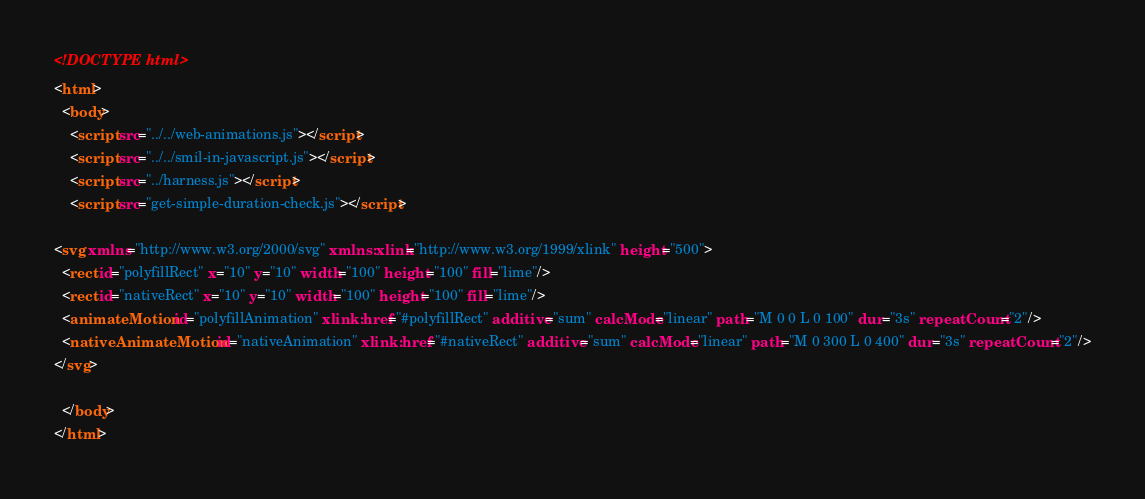<code> <loc_0><loc_0><loc_500><loc_500><_HTML_><!DOCTYPE html>
<html>
  <body>
    <script src="../../web-animations.js"></script>
    <script src="../../smil-in-javascript.js"></script>
    <script src="../harness.js"></script>
    <script src="get-simple-duration-check.js"></script>

<svg xmlns="http://www.w3.org/2000/svg" xmlns:xlink="http://www.w3.org/1999/xlink" height="500">
  <rect id="polyfillRect" x="10" y="10" width="100" height="100" fill="lime"/>
  <rect id="nativeRect" x="10" y="10" width="100" height="100" fill="lime"/>
  <animateMotion id="polyfillAnimation" xlink:href="#polyfillRect" additive="sum" calcMode="linear" path="M 0 0 L 0 100" dur="3s" repeatCount="2"/>
  <nativeAnimateMotion id="nativeAnimation" xlink:href="#nativeRect" additive="sum" calcMode="linear" path="M 0 300 L 0 400" dur="3s" repeatCount="2"/>
</svg>

  </body>
</html>
</code> 